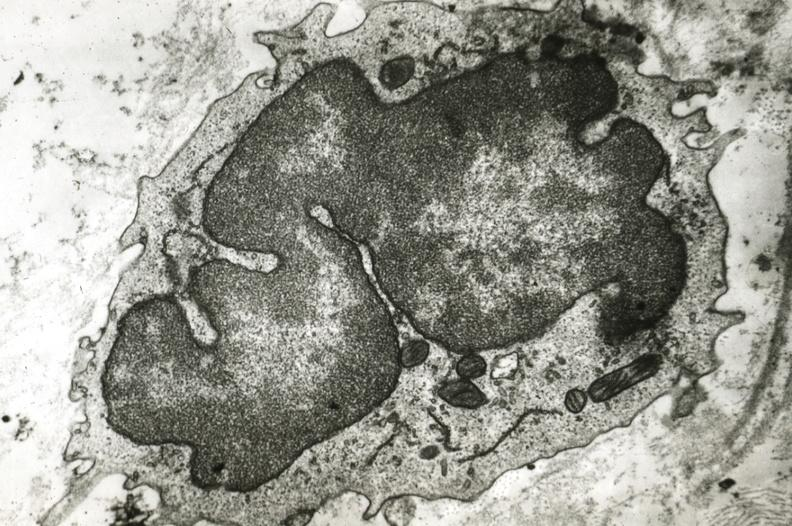what is present?
Answer the question using a single word or phrase. Cardiovascular 